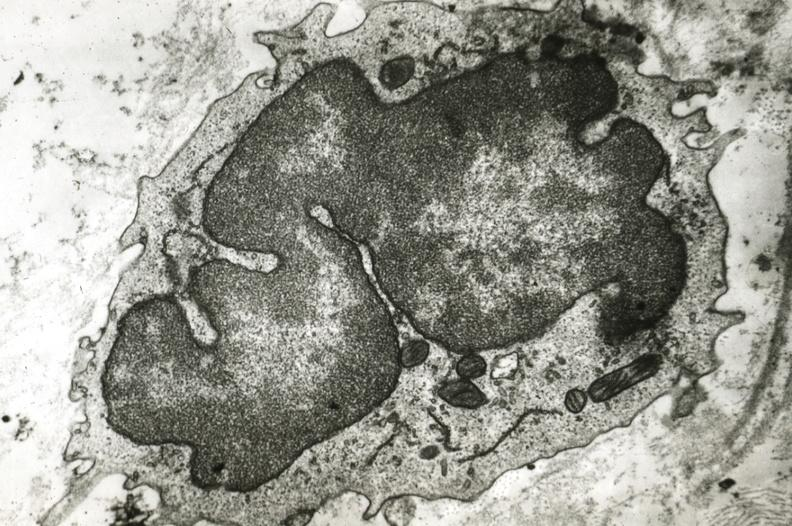what is present?
Answer the question using a single word or phrase. Cardiovascular 